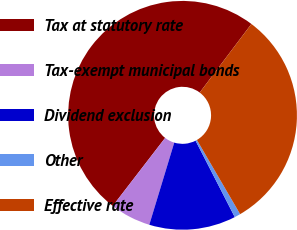<chart> <loc_0><loc_0><loc_500><loc_500><pie_chart><fcel>Tax at statutory rate<fcel>Tax-exempt municipal bonds<fcel>Dividend exclusion<fcel>Other<fcel>Effective rate<nl><fcel>49.83%<fcel>5.75%<fcel>12.24%<fcel>0.85%<fcel>31.32%<nl></chart> 